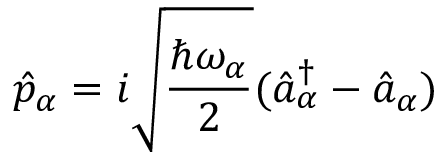Convert formula to latex. <formula><loc_0><loc_0><loc_500><loc_500>\hat { p } _ { \alpha } = i \sqrt { \frac { \hbar { \omega } _ { \alpha } } { 2 } } ( \hat { a } _ { \alpha } ^ { \dag } - \hat { a } _ { \alpha } )</formula> 